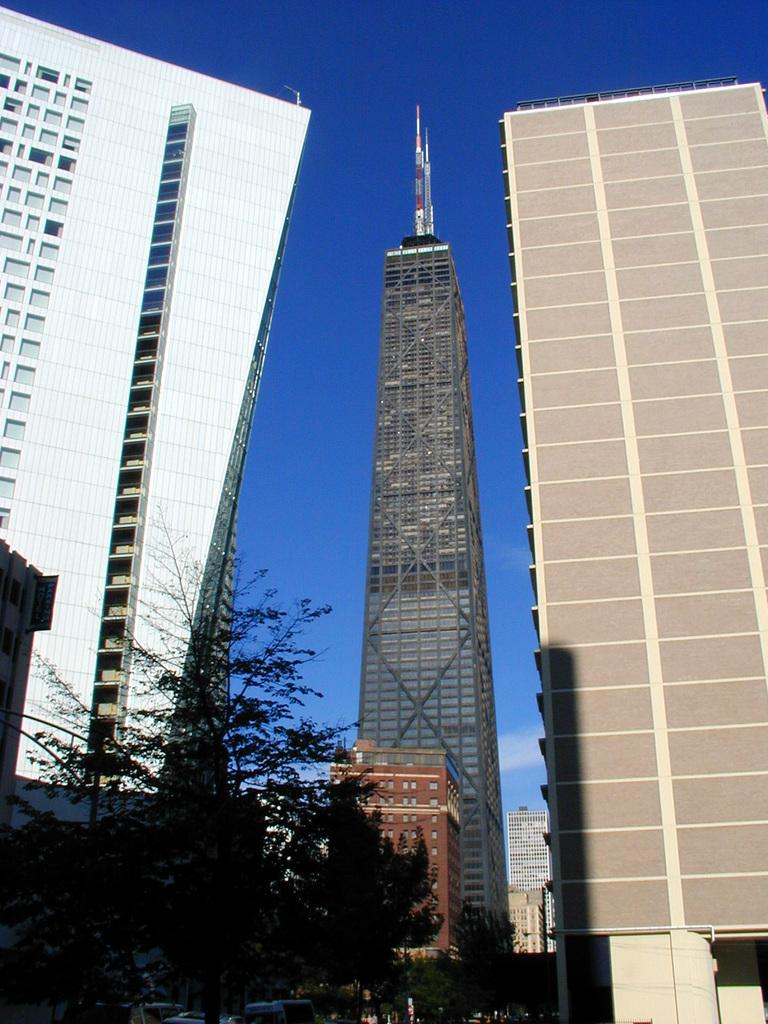What can be seen in the foreground of the picture? There are vehicles and trees in the foreground of the picture. What is located in the center of the picture? There are buildings and skyscrapers in the center of the picture. What is the weather like in the image? The sky is sunny in the image. What type of gate can be seen in the image? There is no gate present in the image. Who is sitting on the throne in the image? There is no throne present in the image. 